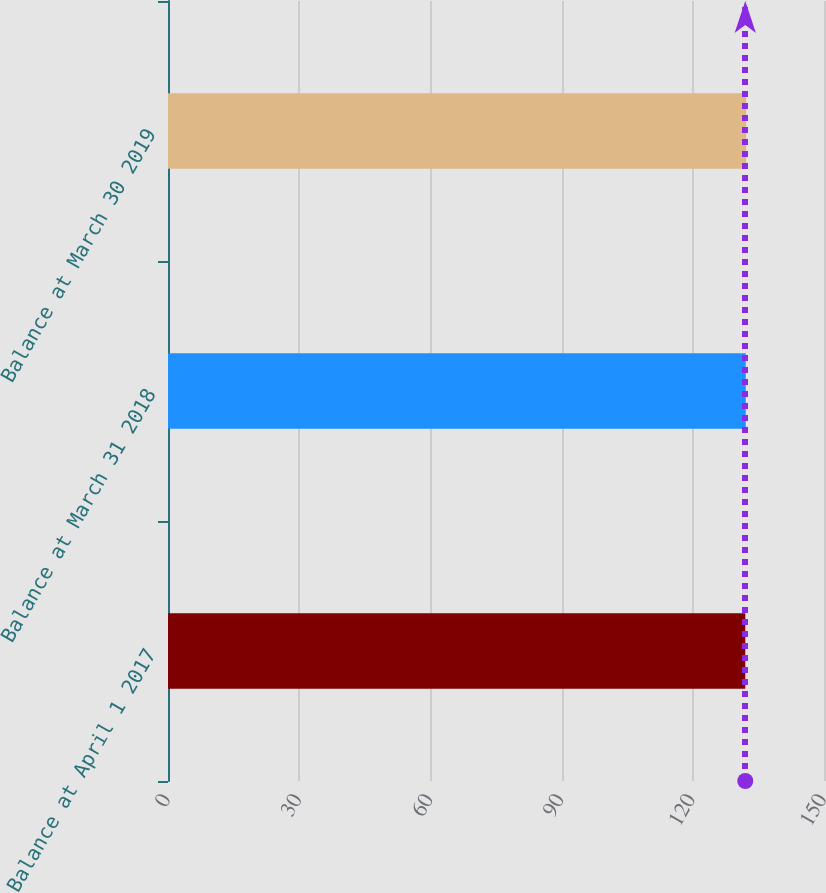Convert chart to OTSL. <chart><loc_0><loc_0><loc_500><loc_500><bar_chart><fcel>Balance at April 1 2017<fcel>Balance at March 31 2018<fcel>Balance at March 30 2019<nl><fcel>132<fcel>132.1<fcel>132.2<nl></chart> 